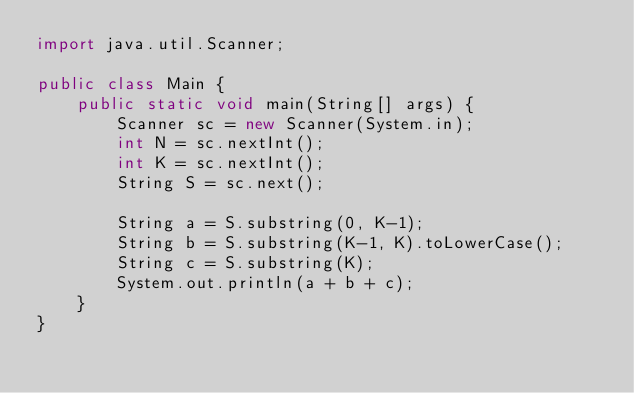<code> <loc_0><loc_0><loc_500><loc_500><_Java_>import java.util.Scanner;

public class Main {
	public static void main(String[] args) {
		Scanner sc = new Scanner(System.in);
		int N = sc.nextInt();
		int K = sc.nextInt();
		String S = sc.next();

		String a = S.substring(0, K-1);
		String b = S.substring(K-1, K).toLowerCase();
		String c = S.substring(K);
		System.out.println(a + b + c);
	}
}</code> 